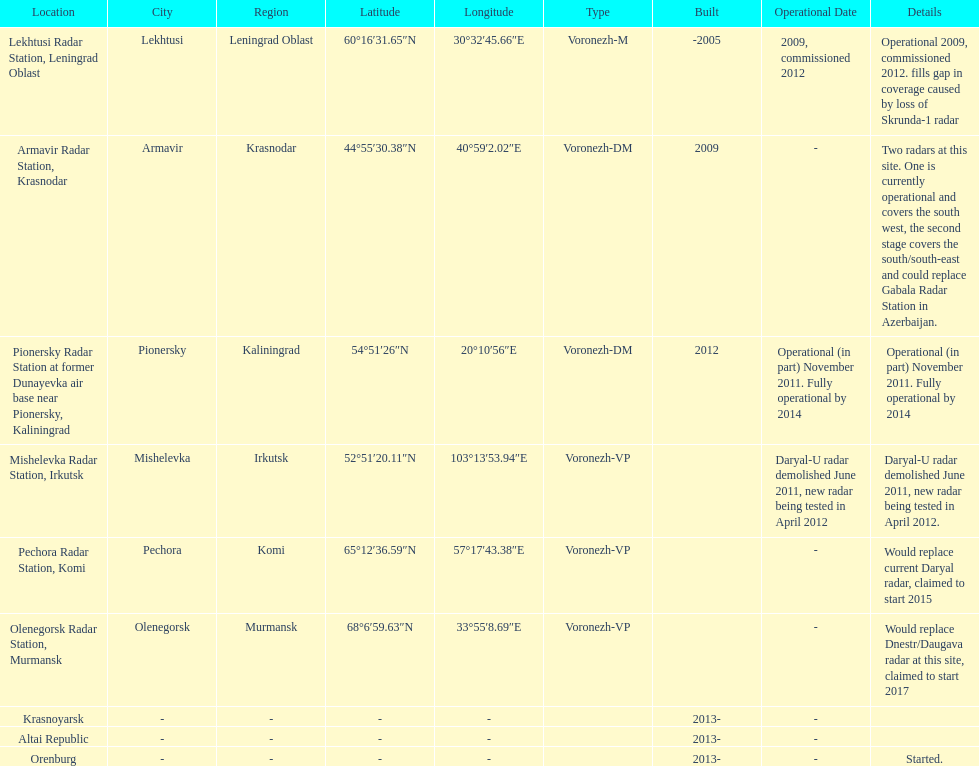What is the total number of locations? 9. 